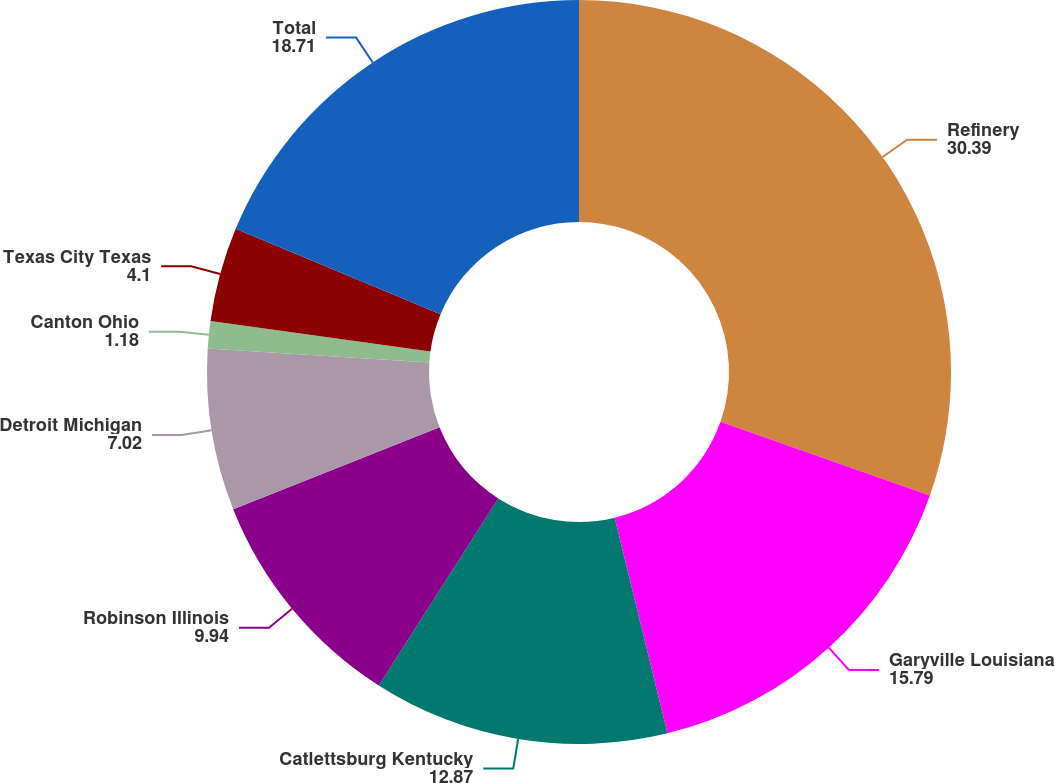<chart> <loc_0><loc_0><loc_500><loc_500><pie_chart><fcel>Refinery<fcel>Garyville Louisiana<fcel>Catlettsburg Kentucky<fcel>Robinson Illinois<fcel>Detroit Michigan<fcel>Canton Ohio<fcel>Texas City Texas<fcel>Total<nl><fcel>30.39%<fcel>15.79%<fcel>12.87%<fcel>9.94%<fcel>7.02%<fcel>1.18%<fcel>4.1%<fcel>18.71%<nl></chart> 